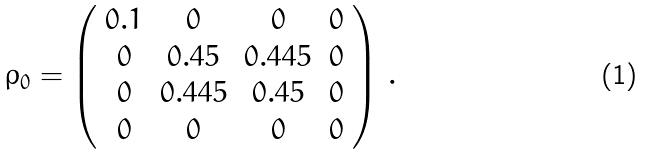Convert formula to latex. <formula><loc_0><loc_0><loc_500><loc_500>\rho _ { 0 } = \left ( \begin{array} { c c c c } 0 . 1 & 0 & 0 & 0 \\ 0 & 0 . 4 5 & 0 . 4 4 5 & 0 \\ 0 & 0 . 4 4 5 & 0 . 4 5 & 0 \\ 0 & 0 & 0 & 0 \\ \end{array} \right ) \, .</formula> 